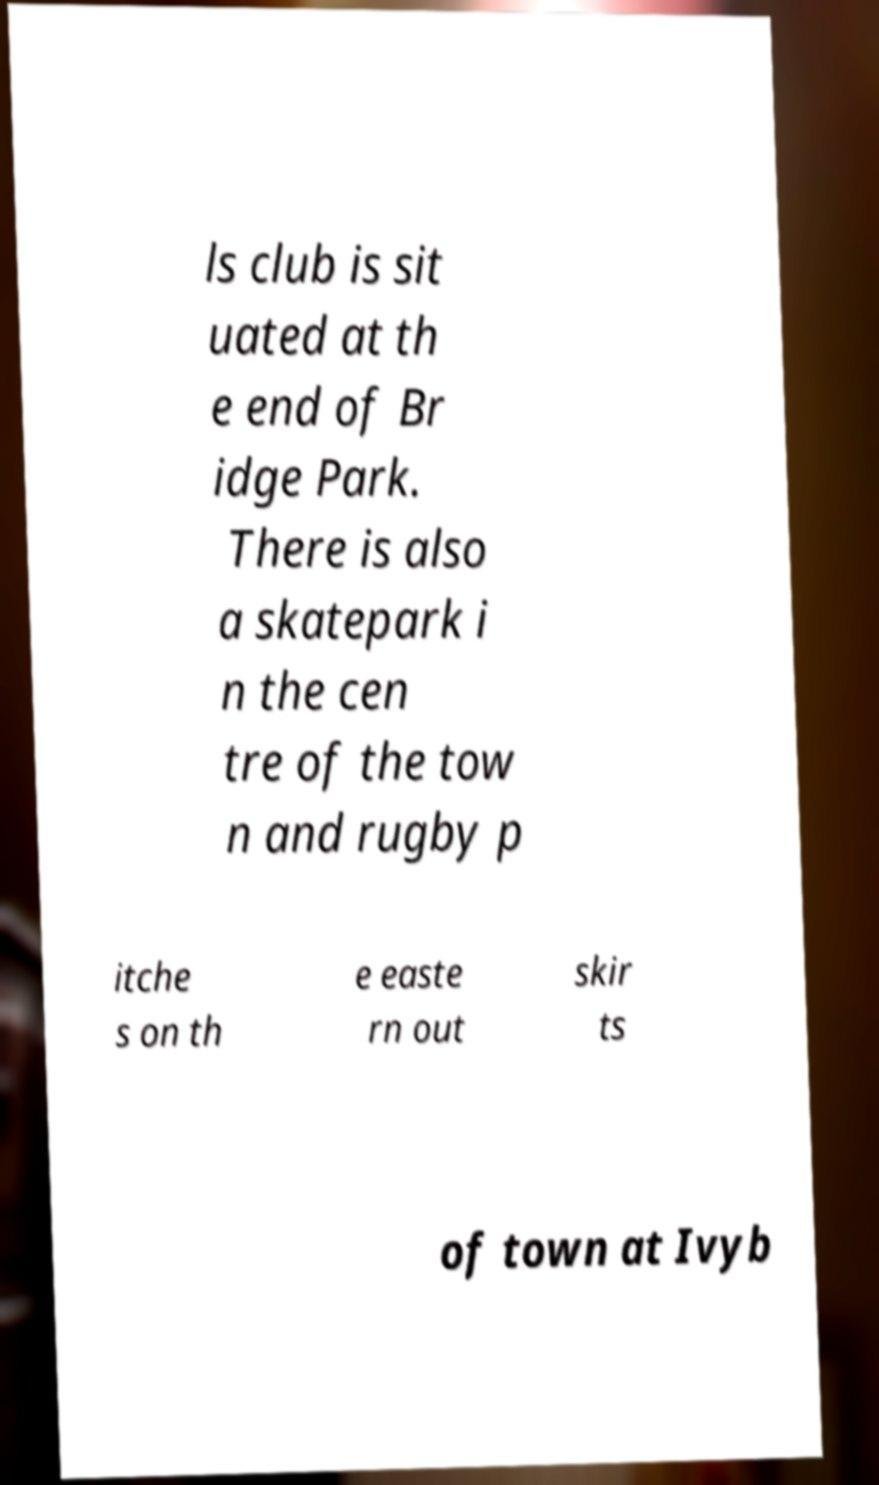I need the written content from this picture converted into text. Can you do that? ls club is sit uated at th e end of Br idge Park. There is also a skatepark i n the cen tre of the tow n and rugby p itche s on th e easte rn out skir ts of town at Ivyb 